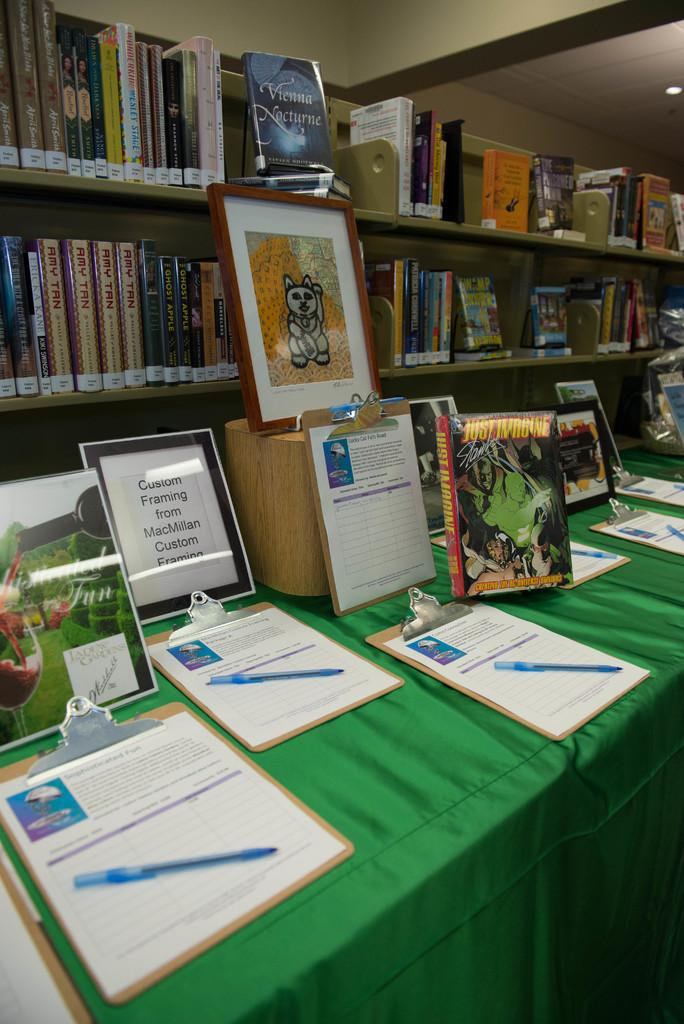<image>
Present a compact description of the photo's key features. Clipboards sit on a table in front of a sign for custom framing by MacMillan Custom Framing. 